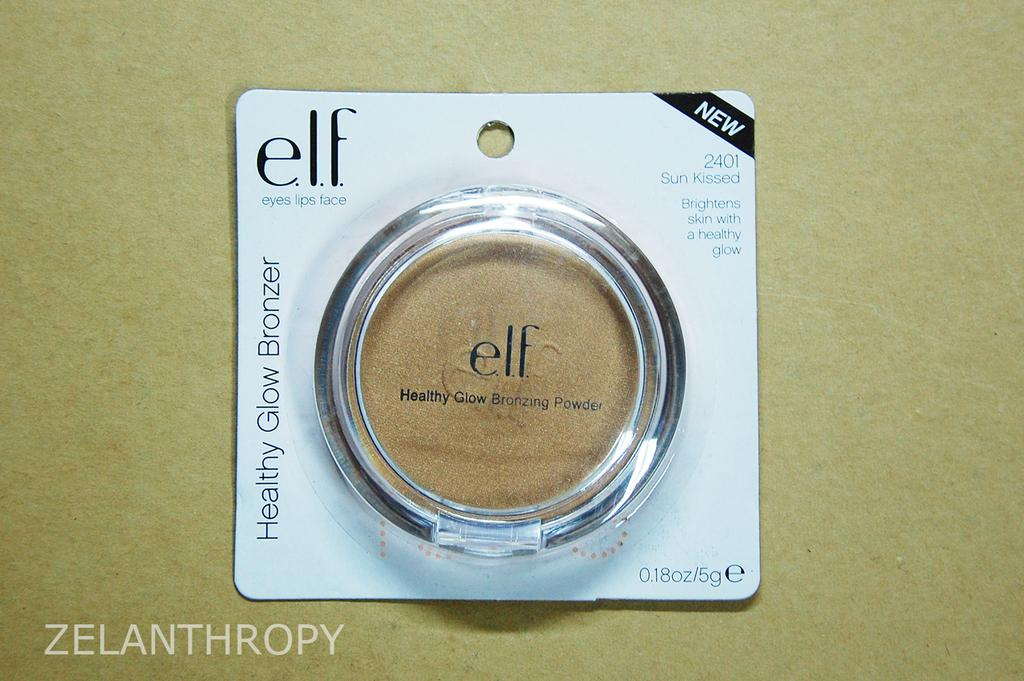<image>
Render a clear and concise summary of the photo. small circle shape of elf glow bronzer in dark beige color 